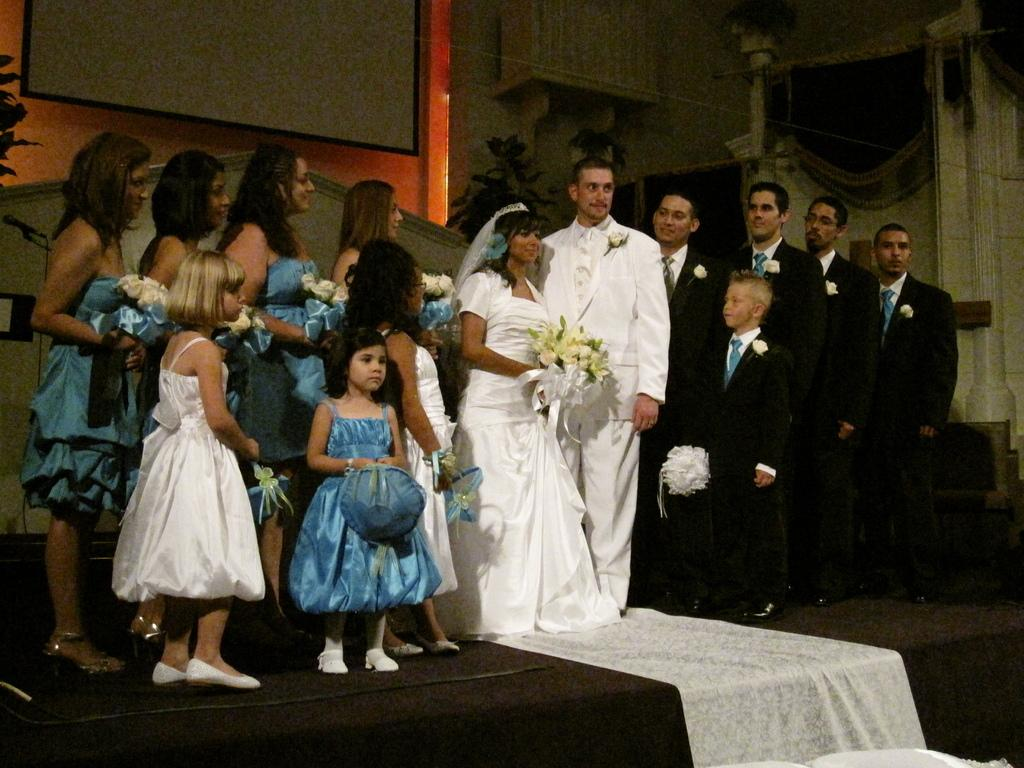What is the location of the person who took the image? The image was taken from inside a church. What can be seen in front of the image? There is a stage in front of the image. What is happening on the stage? There are people standing on the stage. What is visible at the back side of the image? There is a wall at the back side of the image. What flavor of ice cream do the children have with their pets in the image? There are no children, pets, or ice cream present in the image. 